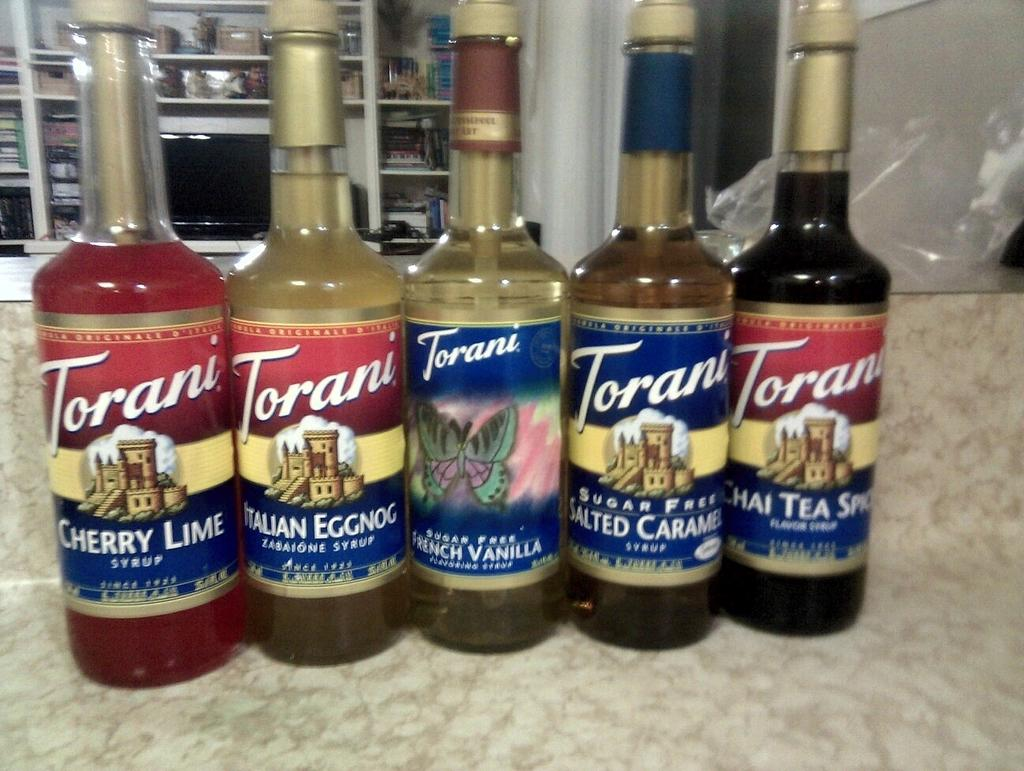<image>
Render a clear and concise summary of the photo. A row of five bottles of syrup the first in line is cherry lime. 